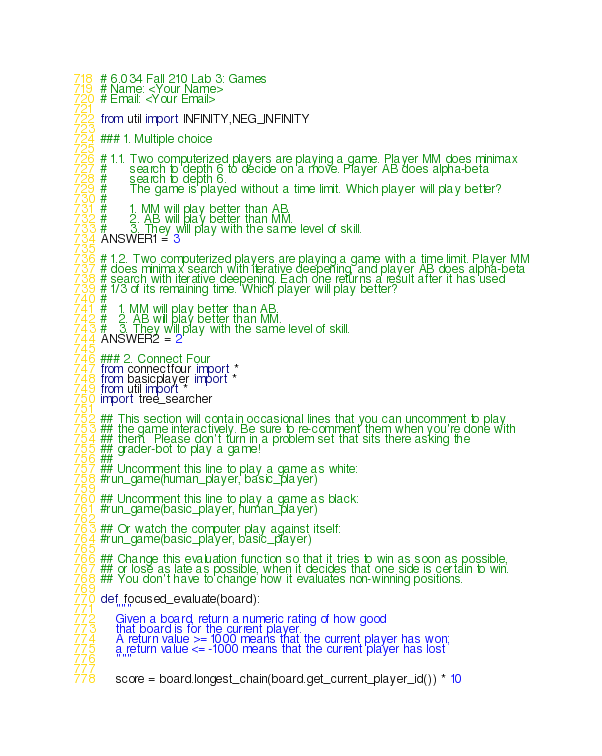<code> <loc_0><loc_0><loc_500><loc_500><_Python_># 6.034 Fall 210 Lab 3: Games
# Name: <Your Name>
# Email: <Your Email>

from util import INFINITY,NEG_INFINITY

### 1. Multiple choice

# 1.1. Two computerized players are playing a game. Player MM does minimax
#      search to depth 6 to decide on a move. Player AB does alpha-beta
#      search to depth 6.
#      The game is played without a time limit. Which player will play better?
#
#      1. MM will play better than AB.
#      2. AB will play better than MM.
#      3. They will play with the same level of skill.
ANSWER1 = 3

# 1.2. Two computerized players are playing a game with a time limit. Player MM
# does minimax search with iterative deepening, and player AB does alpha-beta
# search with iterative deepening. Each one returns a result after it has used
# 1/3 of its remaining time. Which player will play better?
#
#   1. MM will play better than AB.
#   2. AB will play better than MM.
#   3. They will play with the same level of skill.
ANSWER2 = 2

### 2. Connect Four
from connectfour import *
from basicplayer import *
from util import *
import tree_searcher

## This section will contain occasional lines that you can uncomment to play
## the game interactively. Be sure to re-comment them when you're done with
## them.  Please don't turn in a problem set that sits there asking the
## grader-bot to play a game!
## 
## Uncomment this line to play a game as white:
#run_game(human_player, basic_player)

## Uncomment this line to play a game as black:
#run_game(basic_player, human_player)

## Or watch the computer play against itself:
#run_game(basic_player, basic_player)

## Change this evaluation function so that it tries to win as soon as possible,
## or lose as late as possible, when it decides that one side is certain to win.
## You don't have to change how it evaluates non-winning positions.

def focused_evaluate(board):
    """
    Given a board, return a numeric rating of how good
    that board is for the current player.
    A return value >= 1000 means that the current player has won;
    a return value <= -1000 means that the current player has lost
    """
    
    score = board.longest_chain(board.get_current_player_id()) * 10</code> 